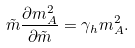<formula> <loc_0><loc_0><loc_500><loc_500>\tilde { m } \frac { \partial m _ { A } ^ { 2 } } { \partial \tilde { m } } = \gamma _ { h } m _ { A } ^ { 2 } .</formula> 